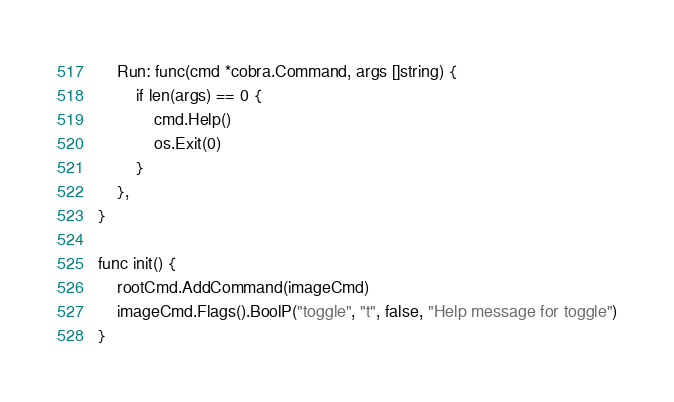<code> <loc_0><loc_0><loc_500><loc_500><_Go_>	Run: func(cmd *cobra.Command, args []string) {
		if len(args) == 0 {
			cmd.Help()
			os.Exit(0)
		}
	},
}

func init() {
	rootCmd.AddCommand(imageCmd)
	imageCmd.Flags().BoolP("toggle", "t", false, "Help message for toggle")
}
</code> 